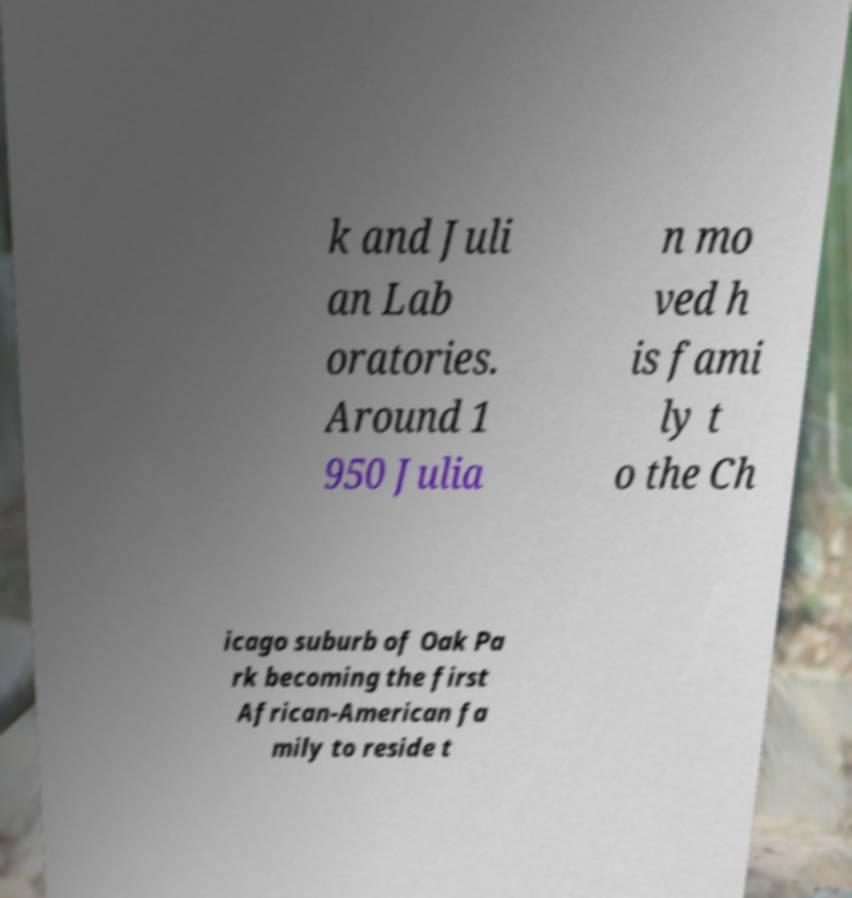Can you read and provide the text displayed in the image?This photo seems to have some interesting text. Can you extract and type it out for me? k and Juli an Lab oratories. Around 1 950 Julia n mo ved h is fami ly t o the Ch icago suburb of Oak Pa rk becoming the first African-American fa mily to reside t 